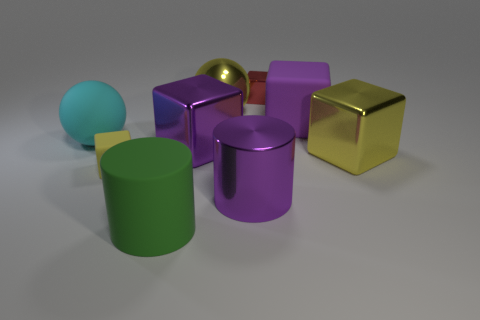Subtract all red blocks. How many blocks are left? 4 Subtract all big yellow cubes. How many cubes are left? 4 Subtract 2 cubes. How many cubes are left? 3 Subtract all gray blocks. Subtract all green spheres. How many blocks are left? 5 Add 1 blocks. How many objects exist? 10 Subtract all cubes. How many objects are left? 4 Subtract 0 gray cubes. How many objects are left? 9 Subtract all large purple objects. Subtract all small cubes. How many objects are left? 4 Add 5 big purple objects. How many big purple objects are left? 8 Add 2 red metal things. How many red metal things exist? 3 